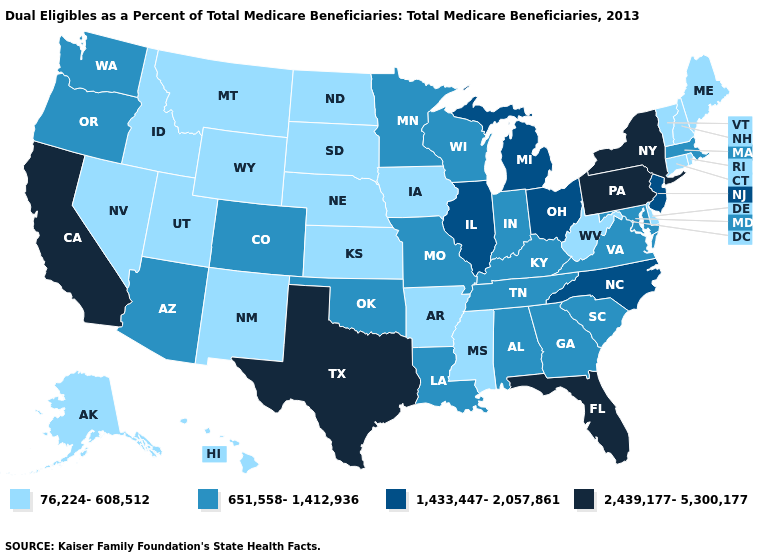What is the highest value in the USA?
Quick response, please. 2,439,177-5,300,177. Does Louisiana have the highest value in the South?
Write a very short answer. No. Does Utah have a lower value than Rhode Island?
Be succinct. No. Which states have the highest value in the USA?
Give a very brief answer. California, Florida, New York, Pennsylvania, Texas. Does Delaware have the lowest value in the South?
Give a very brief answer. Yes. What is the lowest value in the USA?
Concise answer only. 76,224-608,512. Name the states that have a value in the range 2,439,177-5,300,177?
Be succinct. California, Florida, New York, Pennsylvania, Texas. What is the value of Alabama?
Give a very brief answer. 651,558-1,412,936. What is the value of Oklahoma?
Quick response, please. 651,558-1,412,936. Does New Hampshire have the lowest value in the USA?
Concise answer only. Yes. Name the states that have a value in the range 1,433,447-2,057,861?
Short answer required. Illinois, Michigan, New Jersey, North Carolina, Ohio. Name the states that have a value in the range 76,224-608,512?
Answer briefly. Alaska, Arkansas, Connecticut, Delaware, Hawaii, Idaho, Iowa, Kansas, Maine, Mississippi, Montana, Nebraska, Nevada, New Hampshire, New Mexico, North Dakota, Rhode Island, South Dakota, Utah, Vermont, West Virginia, Wyoming. Does California have the highest value in the USA?
Answer briefly. Yes. What is the value of Missouri?
Quick response, please. 651,558-1,412,936. Among the states that border Nebraska , does Missouri have the lowest value?
Quick response, please. No. 